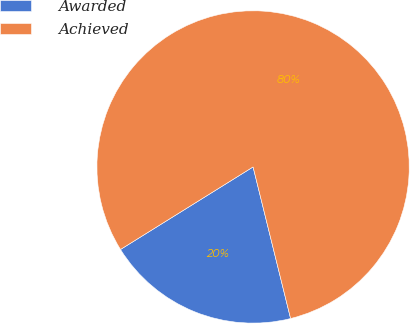<chart> <loc_0><loc_0><loc_500><loc_500><pie_chart><fcel>Awarded<fcel>Achieved<nl><fcel>20.0%<fcel>80.0%<nl></chart> 